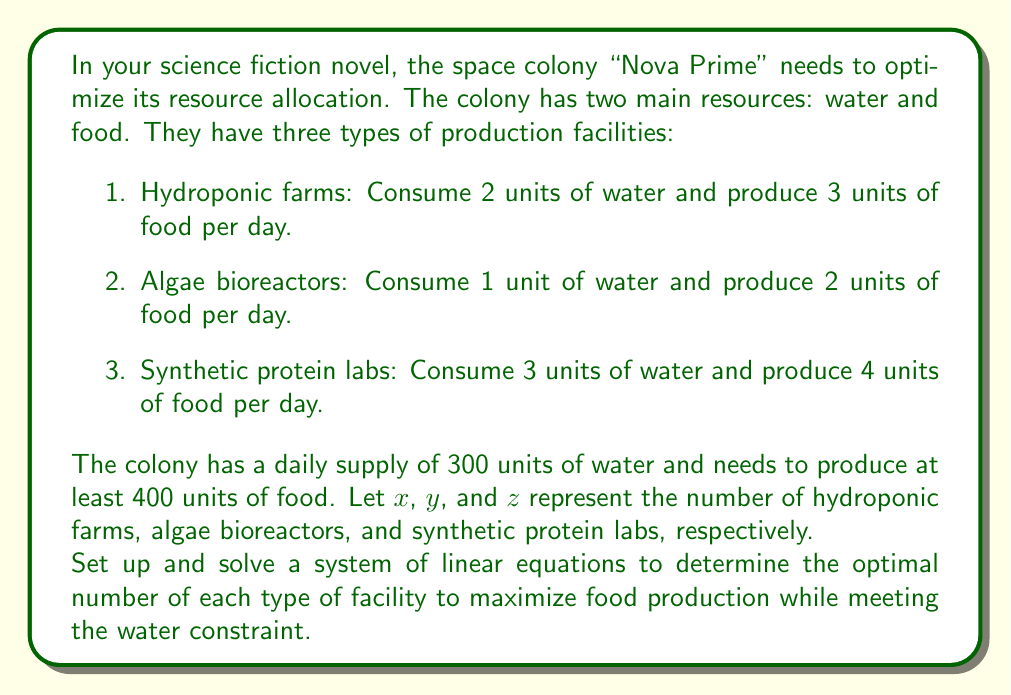Could you help me with this problem? Let's approach this problem step by step:

1. First, we need to set up our constraints:

   Water constraint: $2x + y + 3z \leq 300$
   Food requirement: $3x + 2y + 4z \geq 400$

2. We want to maximize food production, so our objective function is:

   $\text{Maximize } F = 3x + 2y + 4z$

3. To solve this system, we'll convert the inequalities to equations:

   $2x + y + 3z = 300$ (water constraint)
   $3x + 2y + 4z = 400$ (minimum food requirement)

4. Now we have a system of two equations with three variables. To find a unique solution, we need one more equation. Let's introduce a variable $w$ to represent the excess food production:

   $3x + 2y + 4z = 400 + w$

5. Now we have a system of three equations with four variables:

   $$\begin{align}
   2x + y + 3z &= 300 \\
   3x + 2y + 4z &= 400 + w \\
   3x + 2y + 4z &= 400 + w
   \end{align}$$

6. We can solve this system using substitution or elimination. Let's use elimination:

   Multiply the first equation by 3 and subtract from the second:
   $$\begin{align}
   6x + 3y + 9z &= 900 \\
   3x + 2y + 4z &= 400 + w \\
   \hline
   3x + y + 5z &= 500 - w
   \end{align}$$

7. Now we have:
   $$\begin{align}
   2x + y + 3z &= 300 \\
   3x + y + 5z &= 500 - w
   \end{align}$$

   Subtracting the first equation from the second:
   $$x + 2z = 200 - w$$

8. Express $x$ in terms of $z$ and $w$:
   $$x = 200 - w - 2z$$

9. Substitute this into the first equation:
   $$\begin{align}
   2(200 - w - 2z) + y + 3z &= 300 \\
   400 - 2w - 4z + y + 3z &= 300 \\
   400 - 2w - z + y &= 300 \\
   y &= -100 + 2w + z
   \end{align}$$

10. Now we have expressions for $x$ and $y$ in terms of $z$ and $w$. To maximize food production, we want to maximize $w$. However, we need non-negative integer values for $x$, $y$, and $z$.

11. The maximum value for $w$ that gives non-negative integer values for $x$, $y$, and $z$ is 100. This gives:

    $x = 100 - 2z$
    $y = 100 + z$
    
12. To maximize $z$ while keeping $x$ non-negative, $z$ can be at most 50.

13. Therefore, the optimal solution is:
    $x = 0$, $y = 150$, $z = 50$

14. We can verify this solution:
    Water used: $0(2) + 150(1) + 50(3) = 300$
    Food produced: $0(3) + 150(2) + 50(4) = 500$
Answer: The optimal allocation is 0 hydroponic farms, 150 algae bioreactors, and 50 synthetic protein labs, producing a total of 500 units of food per day. 